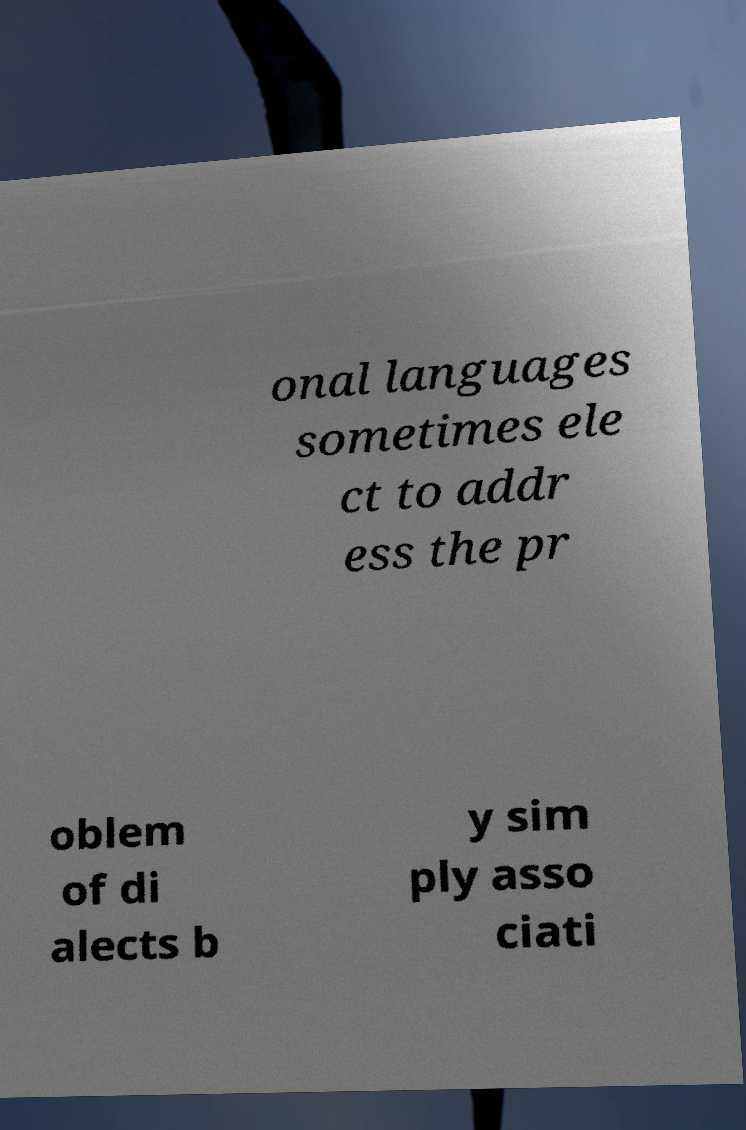What messages or text are displayed in this image? I need them in a readable, typed format. onal languages sometimes ele ct to addr ess the pr oblem of di alects b y sim ply asso ciati 